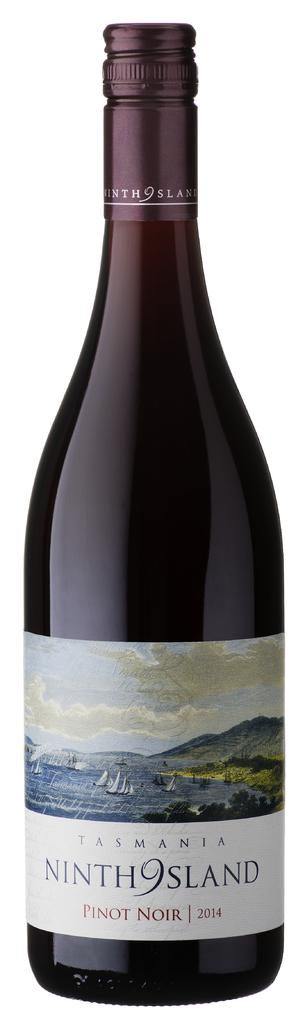<image>
Relay a brief, clear account of the picture shown. A bottle of pinot noir dates back to the year 2014. 